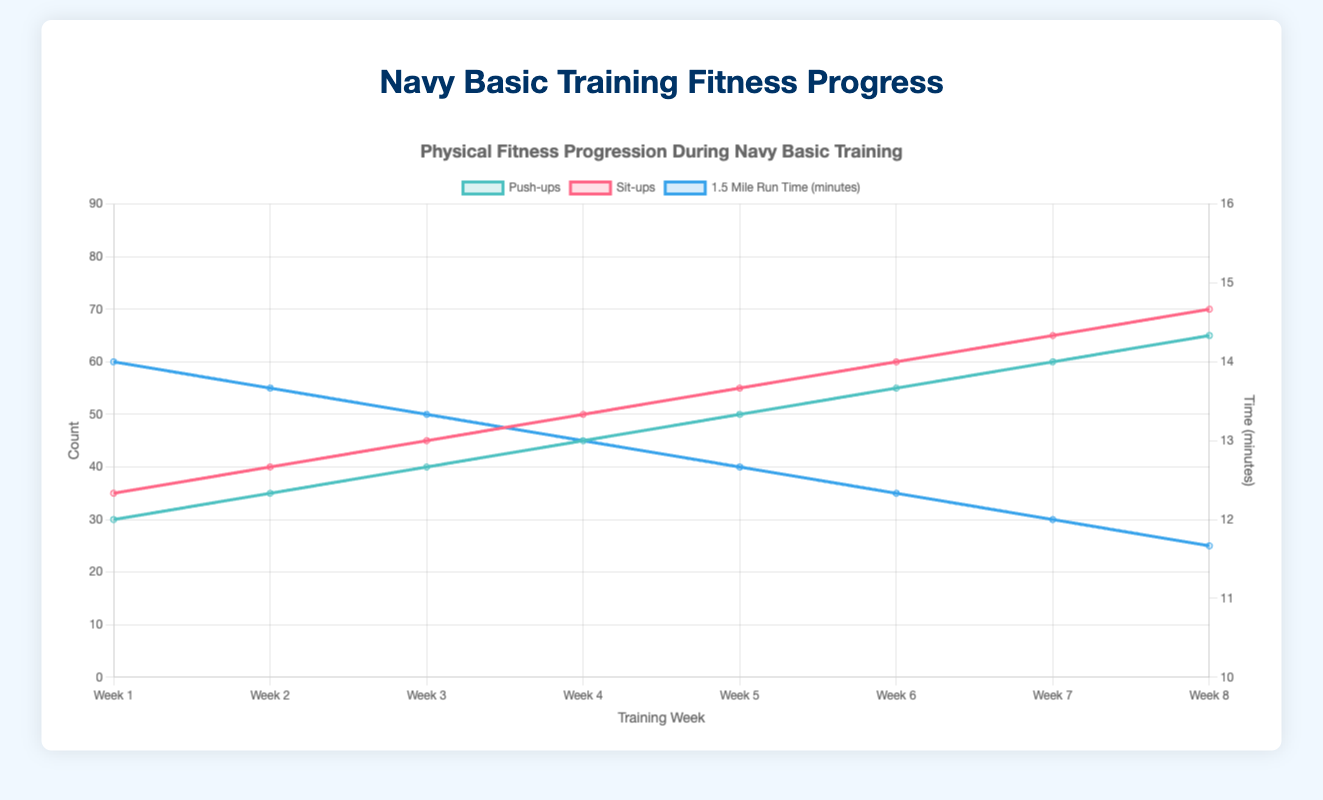What's the average number of push-ups in Week 4? The data point for push-ups in Week 4 shows the average number of push-ups done. The chart will show this as a number plotted on the Y-axis for Week 4.
Answer: 45 How does the average run time in Week 1 compare to the average run time in Week 8? From the chart, convert the average run time from seconds to minutes for both weeks using the equation: average time in minutes = average time in seconds / 60. Compare these values for Week 1 and Week 8. For Week 1, the chart shows 840 seconds (14 minutes). For Week 8, the chart shows 700 seconds (~11.67 minutes). This shows a decrease across the weeks.
Answer: Decreased by 2.33 minutes What was the improvement in the maximum number of sit-ups from Week 3 to Week 8? Find the maximum number of sit-ups for both Week 3 and Week 8 from the chart. For Week 3, the maximum is 60; for Week 8, the maximum is 85. Subtract the two values to find the improvement: 85 - 60.
Answer: 25 Which week shows the highest average push-ups count? Observe the chart to locate the week with the highest average value plotted for push-ups. The highest average value is reached in Week 8, where it is 65.
Answer: Week 8 What is the visual trend for the sit-ups counts over the 8 weeks? Notice the trend of the line plotted for sit-ups count from Week 1 to Week 8. The line slopes upwards, indicating an increasing trend in the average sit-ups count over the training weeks.
Answer: Increasing Compare the average push-ups count between Week 2 and Week 7. From the chart, observe the push-ups averages for Week 2 and Week 7. Week 2 has an average of 35 push-ups, and Week 7 has an average of 60 push-ups. Week 7 has a significantly higher average.
Answer: Week 7 is higher By how much did the minimum 1.5-mile run time (in minutes) decrease from Week 1 to Week 7? Convert the minimum run times from seconds to minutes. In Week 1, 775 seconds is approximately 12.92 minutes; in Week 7, 685 seconds is approximately 11.42 minutes. Calculate the difference: 12.92 - 11.42.
Answer: 1.5 minutes What's the difference between the maximum and minimum sit-ups count in Week 5? Locate the maximum and minimum sit-ups values for Week 5 from the chart. The values are 70 (maximum) and 35 (minimum). Subtract the minimum from the maximum: 70 - 35.
Answer: 35 Which week has the steepest increase in average push-ups count compared to the previous week? Calculate the weekly increase for average push-ups counts and identify the largest difference. The differences for each week are Week2-Week1 = 5, Week3-Week2 = 5, Week4-Week3 = 5, Week5-Week4 = 5, Week6-Week5 = 5, Week7-Week6 = 5, Week8-Week7 = 5. All weeks show the same increase.
Answer: All weeks are equal Which week shows the smallest maximum 1.5-mile run time? From the chart, look for the lowest maximum run time value among all weeks. Week 8 shows the smallest maximum time, which is 760 seconds (approximately 12.67 minutes).
Answer: Week 8 